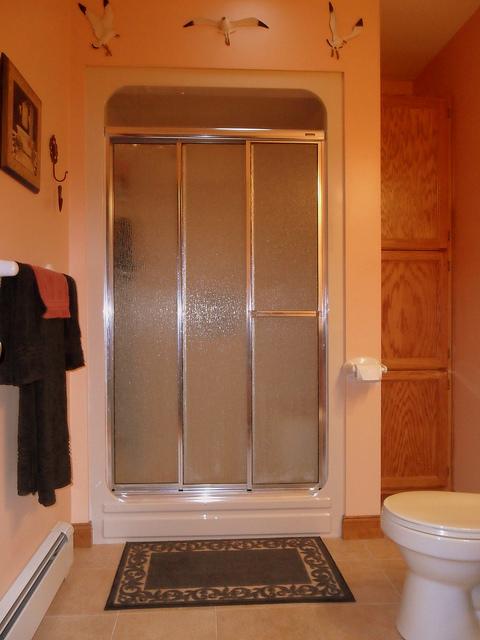Are the towels clean?
Quick response, please. Yes. What type is this shower or steam bath?
Give a very brief answer. Shower. What color is the floor mat?
Answer briefly. Gray. Is this room clean?
Be succinct. Yes. 